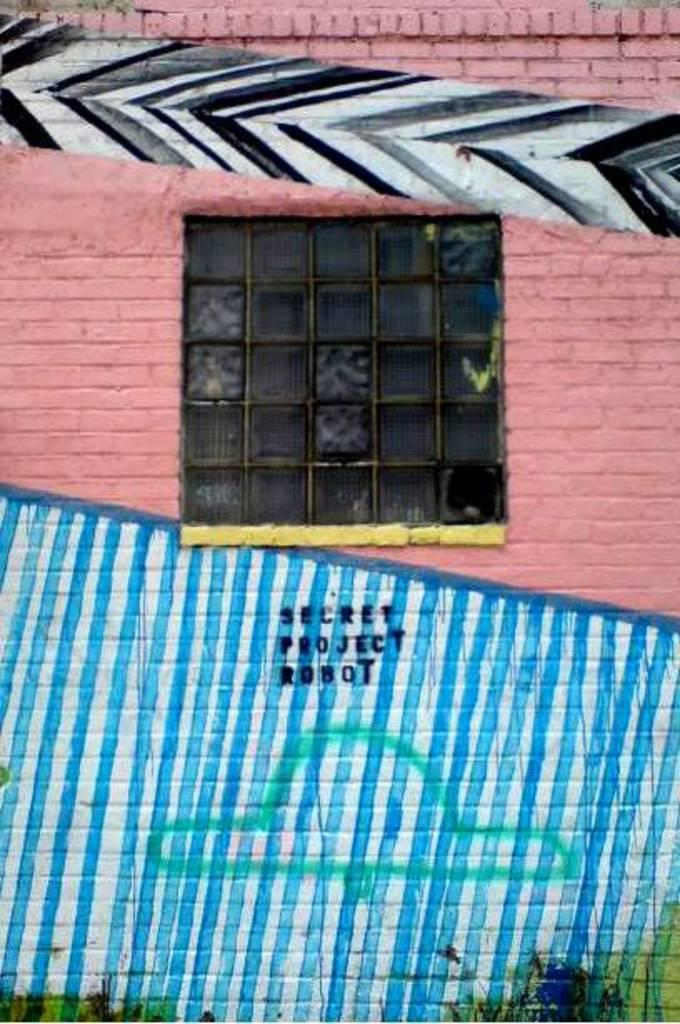What type of artwork can be seen on the wall in the image? There are paintings on the wall in the image. What architectural feature is present in the middle of the image? There is a window in the middle of the image. What type of instrument is being played near the window in the image? There is no instrument or person playing an instrument present in the image. Where is the faucet located in the image? There is no faucet present in the image. 